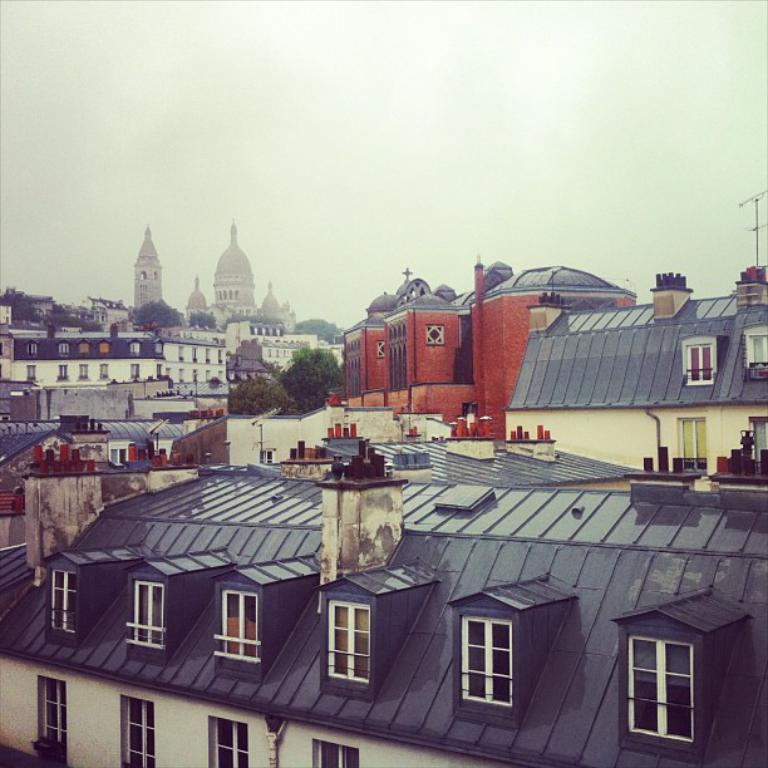What types of structures can be seen in the image? There are multiple buildings in the image. What natural elements are present in the image? There are trees in the image. What is the name of the pot in the image? There is no pot present in the image. Can you draw a circle around the name of the person in the image? There are no names of people in the image. 